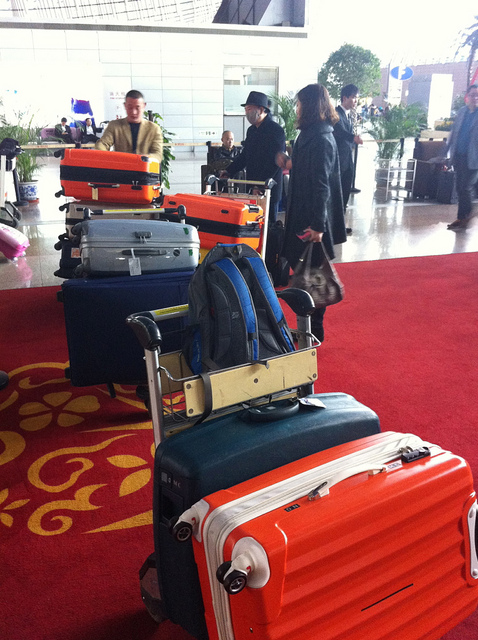What might be the destination of the travelers in the background? Based on their attire and the suitcases, the travelers could be headed to a location that caters to business or professional events. However, without more context, it's impossible to determine their exact destination. 